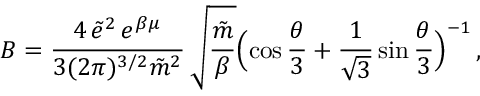Convert formula to latex. <formula><loc_0><loc_0><loc_500><loc_500>B = \frac { 4 \, \tilde { e } ^ { 2 } \, e ^ { \beta \mu } } { 3 ( 2 \pi ) ^ { 3 / 2 } \tilde { m } ^ { 2 } } \, \sqrt { \frac { \tilde { m } } { \beta } } \left ( \cos \frac { \theta } { 3 } + \frac { 1 } { \sqrt { 3 } } \sin \frac { \theta } { 3 } \right ) ^ { - 1 } \, ,</formula> 